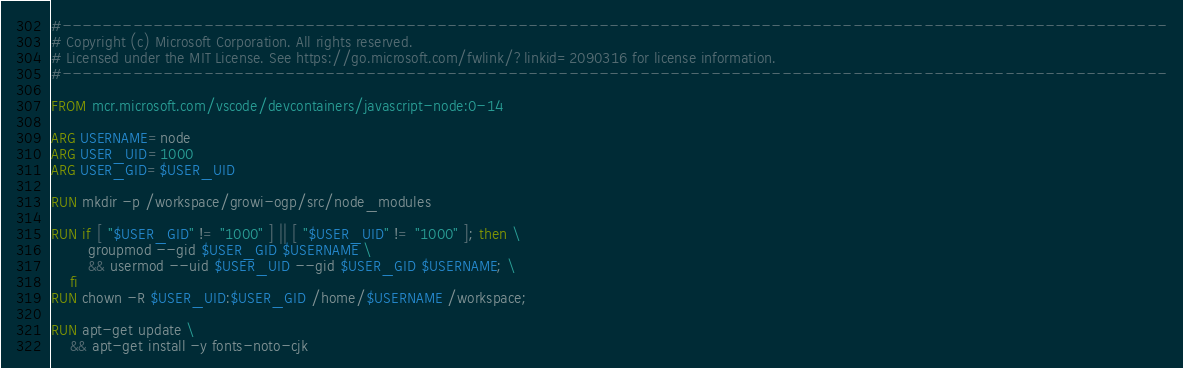<code> <loc_0><loc_0><loc_500><loc_500><_Dockerfile_>#-------------------------------------------------------------------------------------------------------------
# Copyright (c) Microsoft Corporation. All rights reserved.
# Licensed under the MIT License. See https://go.microsoft.com/fwlink/?linkid=2090316 for license information.
#-------------------------------------------------------------------------------------------------------------

FROM mcr.microsoft.com/vscode/devcontainers/javascript-node:0-14

ARG USERNAME=node
ARG USER_UID=1000
ARG USER_GID=$USER_UID

RUN mkdir -p /workspace/growi-ogp/src/node_modules

RUN if [ "$USER_GID" != "1000" ] || [ "$USER_UID" != "1000" ]; then \
        groupmod --gid $USER_GID $USERNAME \
        && usermod --uid $USER_UID --gid $USER_GID $USERNAME; \
    fi
RUN chown -R $USER_UID:$USER_GID /home/$USERNAME /workspace;

RUN apt-get update \
    && apt-get install -y fonts-noto-cjk
</code> 